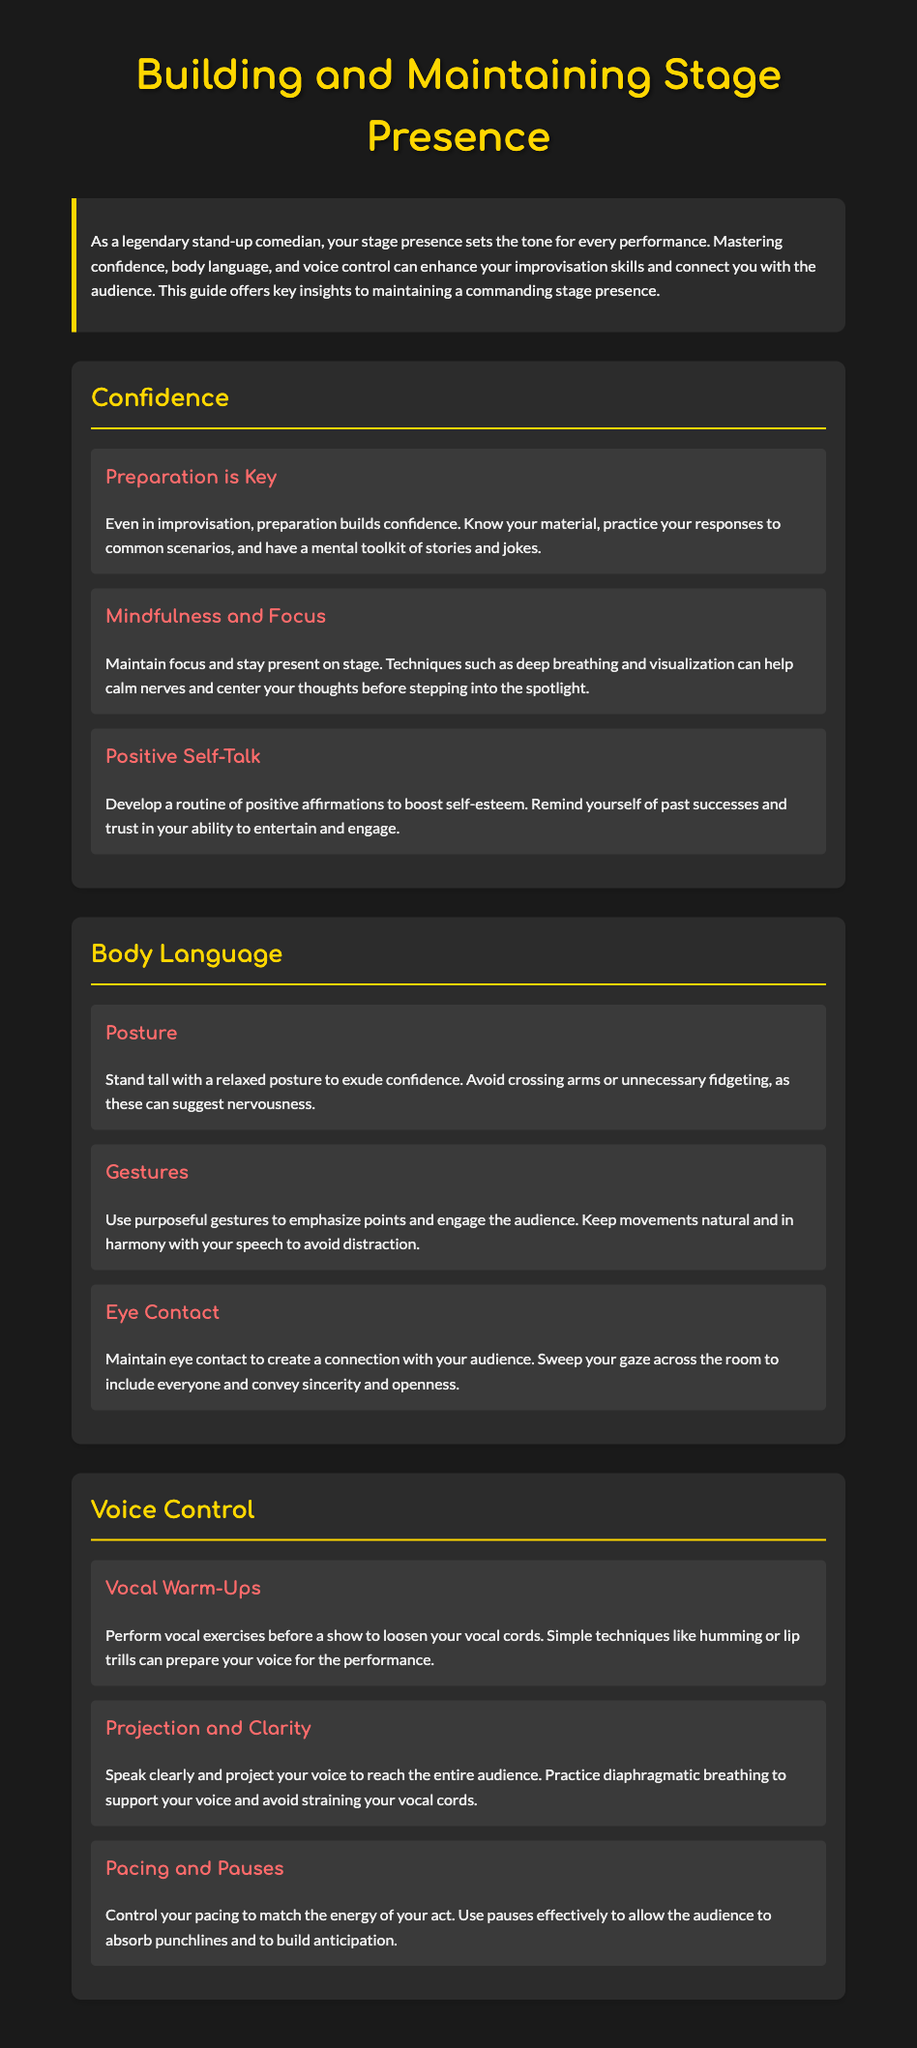What is the main topic of the guide? The main topic is about building and maintaining stage presence for stand-up comedians.
Answer: stage presence What three areas are covered in the guide? The areas covered in the guide include confidence, body language, and voice control.
Answer: confidence, body language, voice control What key aspect builds confidence according to the guide? Preparation is highlighted as a key aspect that builds confidence.
Answer: preparation What should you avoid doing with your arms while on stage? The guide suggests avoiding crossing arms to prevent signaling nervousness.
Answer: crossing arms What vocal technique is recommended before a performance? The guide recommends performing vocal warm-ups as a technique before a show.
Answer: vocal warm-ups What is a recommended method to create a connection with the audience? Maintaining eye contact is the recommended method to create a connection.
Answer: eye contact How should your posture be while performing? The guide states that you should stand tall with a relaxed posture.
Answer: relaxed posture What is the suggested role of pauses in a comedy act? Pauses are suggested to build anticipation and allow the audience to absorb punchlines.
Answer: build anticipation What does diaphragmatic breathing help with? Diaphragmatic breathing helps to support your voice and avoid straining vocal cords.
Answer: support your voice 